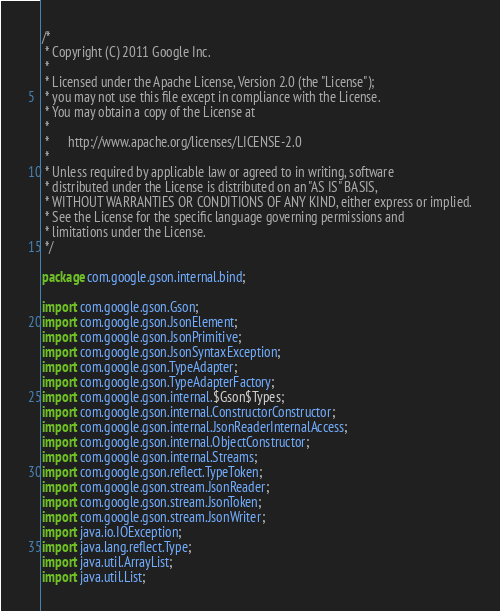Convert code to text. <code><loc_0><loc_0><loc_500><loc_500><_Java_>/*
 * Copyright (C) 2011 Google Inc.
 *
 * Licensed under the Apache License, Version 2.0 (the "License");
 * you may not use this file except in compliance with the License.
 * You may obtain a copy of the License at
 *
 *      http://www.apache.org/licenses/LICENSE-2.0
 *
 * Unless required by applicable law or agreed to in writing, software
 * distributed under the License is distributed on an "AS IS" BASIS,
 * WITHOUT WARRANTIES OR CONDITIONS OF ANY KIND, either express or implied.
 * See the License for the specific language governing permissions and
 * limitations under the License.
 */

package com.google.gson.internal.bind;

import com.google.gson.Gson;
import com.google.gson.JsonElement;
import com.google.gson.JsonPrimitive;
import com.google.gson.JsonSyntaxException;
import com.google.gson.TypeAdapter;
import com.google.gson.TypeAdapterFactory;
import com.google.gson.internal.$Gson$Types;
import com.google.gson.internal.ConstructorConstructor;
import com.google.gson.internal.JsonReaderInternalAccess;
import com.google.gson.internal.ObjectConstructor;
import com.google.gson.internal.Streams;
import com.google.gson.reflect.TypeToken;
import com.google.gson.stream.JsonReader;
import com.google.gson.stream.JsonToken;
import com.google.gson.stream.JsonWriter;
import java.io.IOException;
import java.lang.reflect.Type;
import java.util.ArrayList;
import java.util.List;</code> 